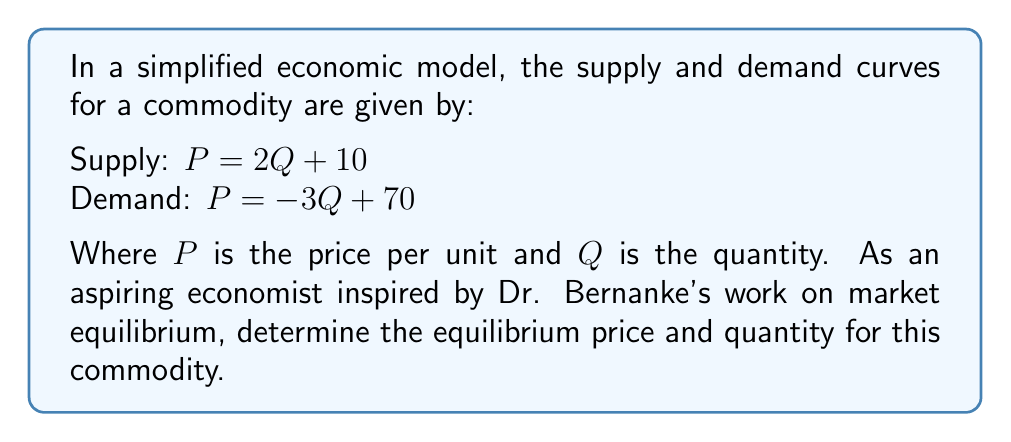Help me with this question. To find the equilibrium point, we need to solve the system of equations where supply equals demand:

1) Set the two equations equal to each other:
   $2Q + 10 = -3Q + 70$

2) Solve for Q:
   $2Q + 3Q = 70 - 10$
   $5Q = 60$
   $Q = 12$

3) Now that we know the equilibrium quantity, we can substitute this value into either the supply or demand equation to find the equilibrium price. Let's use the supply equation:

   $P = 2Q + 10$
   $P = 2(12) + 10$
   $P = 24 + 10 = 34$

4) Therefore, the equilibrium point is at quantity $Q = 12$ and price $P = 34$.

This approach demonstrates the market-clearing mechanism that Dr. Bernanke often discussed in his work on macroeconomics, where prices adjust to balance supply and demand.
Answer: $(12, 34)$ 